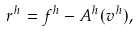<formula> <loc_0><loc_0><loc_500><loc_500>r ^ { h } = f ^ { h } - A ^ { h } ( v ^ { h } ) ,</formula> 